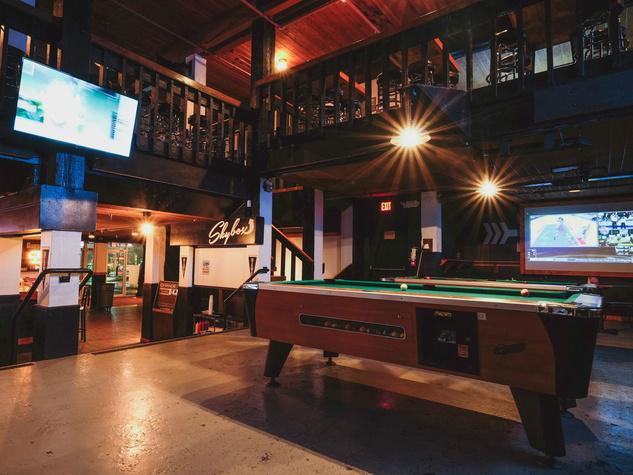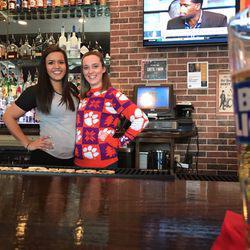The first image is the image on the left, the second image is the image on the right. For the images shown, is this caption "One image shows two camera-facing smiling women posed side-by-side behind a table-like surface." true? Answer yes or no. Yes. The first image is the image on the left, the second image is the image on the right. Evaluate the accuracy of this statement regarding the images: "One scoreboard is lit up with neon red and yellow colors.". Is it true? Answer yes or no. No. 